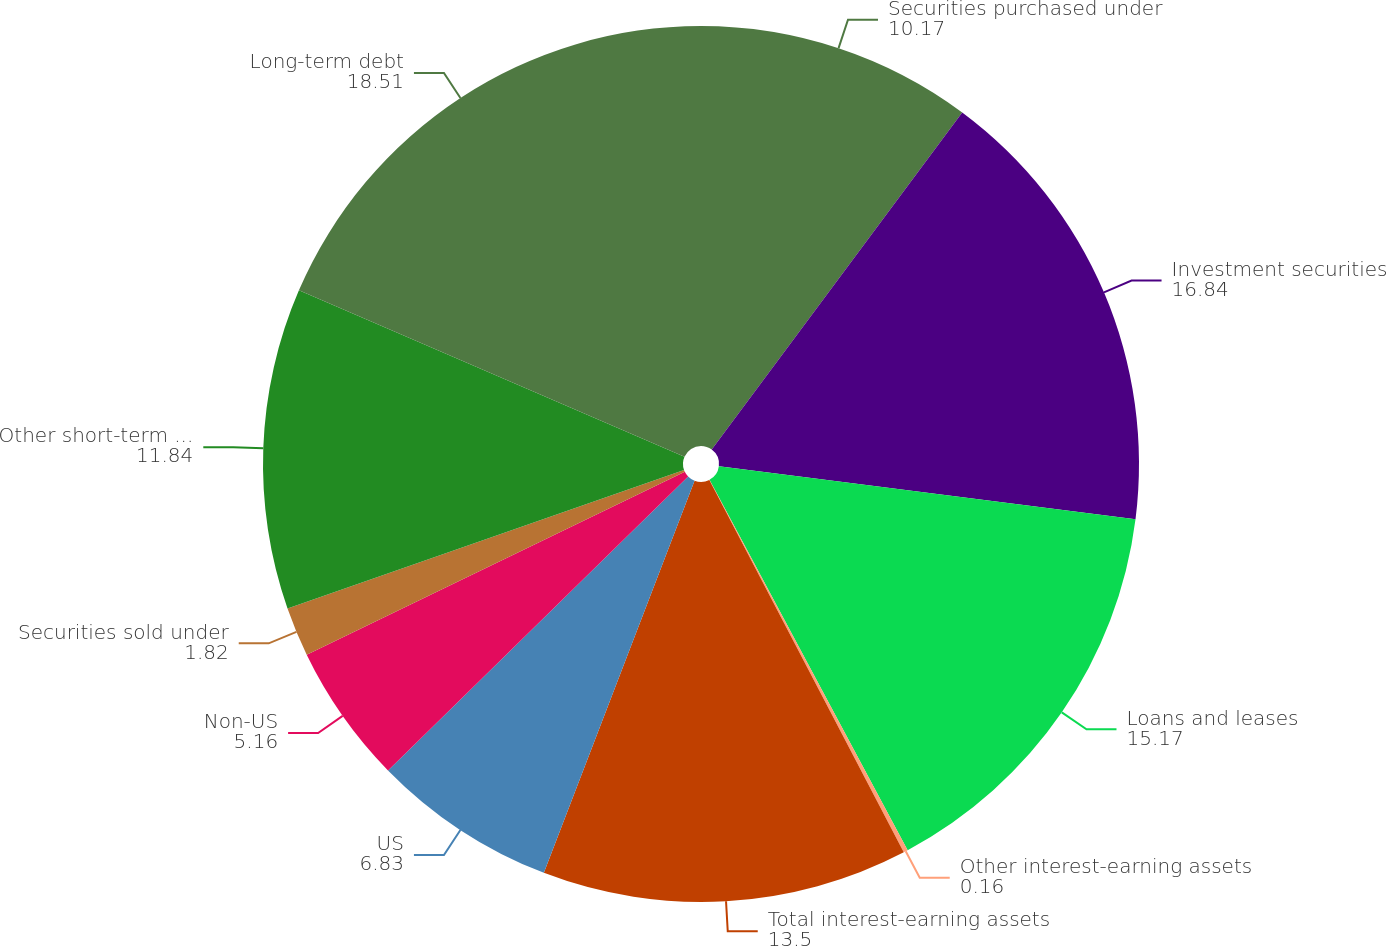<chart> <loc_0><loc_0><loc_500><loc_500><pie_chart><fcel>Securities purchased under<fcel>Investment securities<fcel>Loans and leases<fcel>Other interest-earning assets<fcel>Total interest-earning assets<fcel>US<fcel>Non-US<fcel>Securities sold under<fcel>Other short-term borrowings<fcel>Long-term debt<nl><fcel>10.17%<fcel>16.84%<fcel>15.17%<fcel>0.16%<fcel>13.5%<fcel>6.83%<fcel>5.16%<fcel>1.82%<fcel>11.84%<fcel>18.51%<nl></chart> 